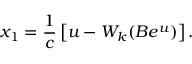<formula> <loc_0><loc_0><loc_500><loc_500>x _ { 1 } = \frac { 1 } { c } \left [ u - W _ { k } ( B e ^ { u } ) \right ] .</formula> 